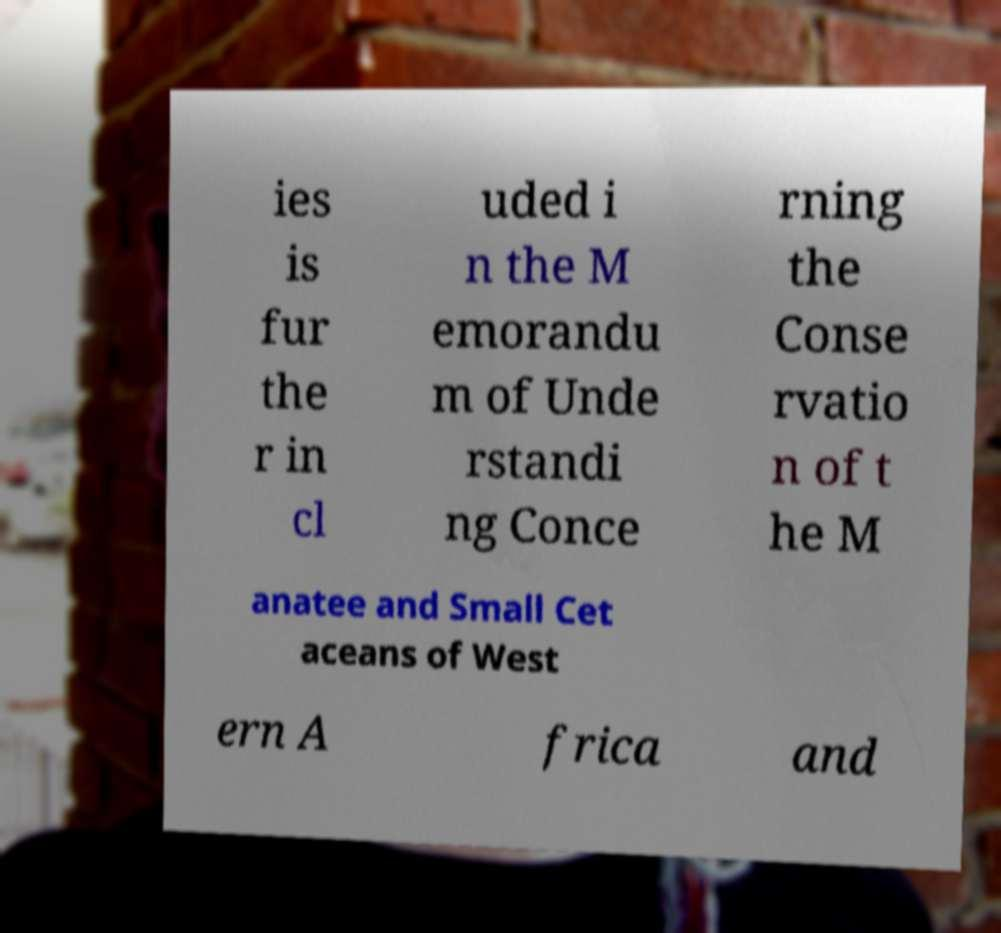Could you assist in decoding the text presented in this image and type it out clearly? ies is fur the r in cl uded i n the M emorandu m of Unde rstandi ng Conce rning the Conse rvatio n of t he M anatee and Small Cet aceans of West ern A frica and 